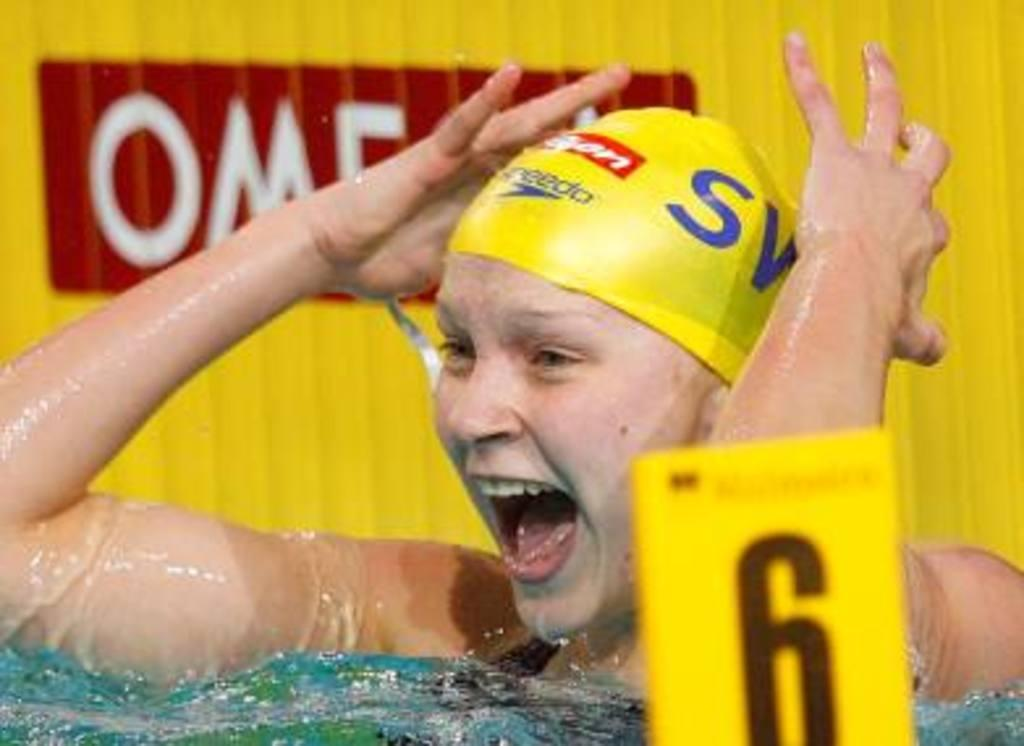What is the person in the image doing? The person is in the water in the image. What else can be seen in the image besides the person? There is a board in the image. Can you describe the yellow board in the background? There is a yellow color board in the background of the image, and there is text written on it. What type of owl can be seen learning on the board in the image? There is no owl present in the image, and the person is not learning on the board. 